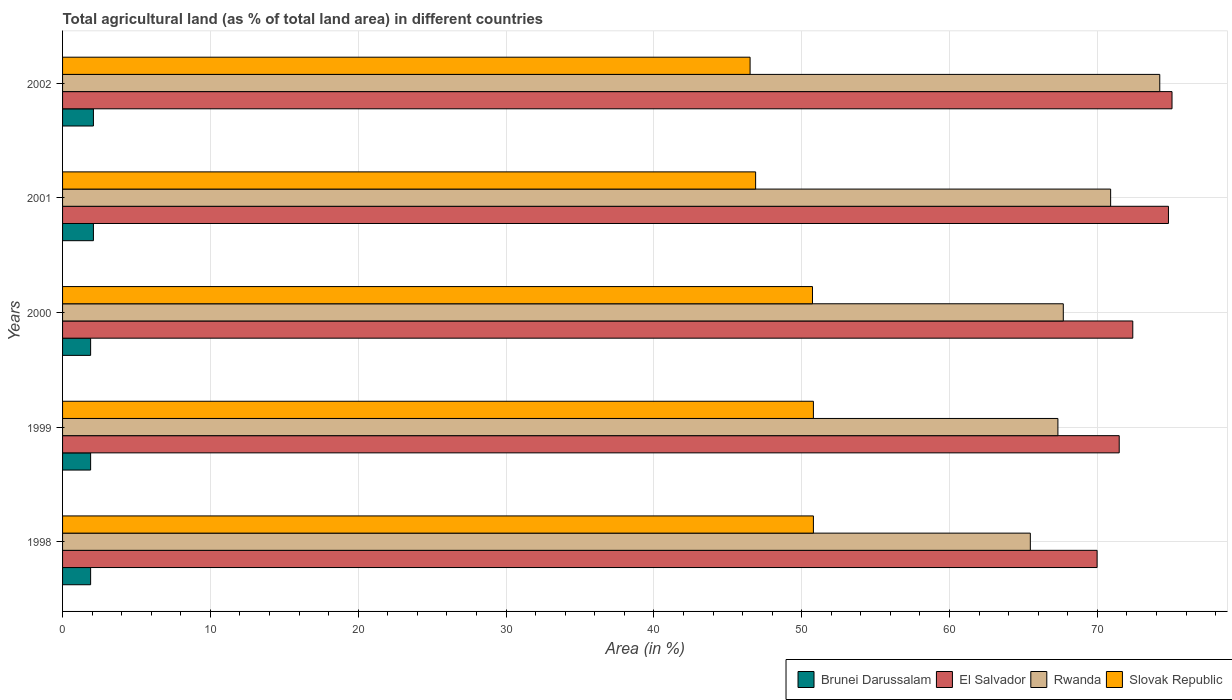How many different coloured bars are there?
Your response must be concise. 4. How many groups of bars are there?
Keep it short and to the point. 5. Are the number of bars per tick equal to the number of legend labels?
Your answer should be very brief. Yes. How many bars are there on the 1st tick from the bottom?
Ensure brevity in your answer.  4. What is the label of the 5th group of bars from the top?
Keep it short and to the point. 1998. In how many cases, is the number of bars for a given year not equal to the number of legend labels?
Ensure brevity in your answer.  0. What is the percentage of agricultural land in Brunei Darussalam in 1999?
Provide a succinct answer. 1.9. Across all years, what is the maximum percentage of agricultural land in El Salvador?
Provide a succinct answer. 75.05. Across all years, what is the minimum percentage of agricultural land in Slovak Republic?
Ensure brevity in your answer.  46.51. In which year was the percentage of agricultural land in Slovak Republic maximum?
Give a very brief answer. 1998. In which year was the percentage of agricultural land in Rwanda minimum?
Your answer should be very brief. 1998. What is the total percentage of agricultural land in El Salvador in the graph?
Provide a short and direct response. 363.71. What is the difference between the percentage of agricultural land in El Salvador in 1999 and that in 2000?
Provide a succinct answer. -0.92. What is the difference between the percentage of agricultural land in Rwanda in 2000 and the percentage of agricultural land in Slovak Republic in 2001?
Ensure brevity in your answer.  20.81. What is the average percentage of agricultural land in Slovak Republic per year?
Your answer should be very brief. 49.14. In the year 2002, what is the difference between the percentage of agricultural land in Rwanda and percentage of agricultural land in Slovak Republic?
Provide a succinct answer. 27.71. In how many years, is the percentage of agricultural land in Brunei Darussalam greater than 14 %?
Your answer should be very brief. 0. What is the ratio of the percentage of agricultural land in El Salvador in 1998 to that in 2000?
Your response must be concise. 0.97. What is the difference between the highest and the second highest percentage of agricultural land in Rwanda?
Provide a succinct answer. 3.32. What is the difference between the highest and the lowest percentage of agricultural land in Slovak Republic?
Keep it short and to the point. 4.28. Is it the case that in every year, the sum of the percentage of agricultural land in El Salvador and percentage of agricultural land in Slovak Republic is greater than the sum of percentage of agricultural land in Rwanda and percentage of agricultural land in Brunei Darussalam?
Offer a terse response. Yes. What does the 4th bar from the top in 1999 represents?
Offer a very short reply. Brunei Darussalam. What does the 1st bar from the bottom in 2001 represents?
Your response must be concise. Brunei Darussalam. Are all the bars in the graph horizontal?
Ensure brevity in your answer.  Yes. What is the difference between two consecutive major ticks on the X-axis?
Keep it short and to the point. 10. Does the graph contain grids?
Keep it short and to the point. Yes. How are the legend labels stacked?
Provide a short and direct response. Horizontal. What is the title of the graph?
Give a very brief answer. Total agricultural land (as % of total land area) in different countries. Does "Brunei Darussalam" appear as one of the legend labels in the graph?
Ensure brevity in your answer.  Yes. What is the label or title of the X-axis?
Provide a succinct answer. Area (in %). What is the label or title of the Y-axis?
Your response must be concise. Years. What is the Area (in %) of Brunei Darussalam in 1998?
Provide a succinct answer. 1.9. What is the Area (in %) of El Salvador in 1998?
Provide a succinct answer. 69.98. What is the Area (in %) in Rwanda in 1998?
Provide a succinct answer. 65.46. What is the Area (in %) of Slovak Republic in 1998?
Your answer should be very brief. 50.79. What is the Area (in %) in Brunei Darussalam in 1999?
Your response must be concise. 1.9. What is the Area (in %) of El Salvador in 1999?
Your answer should be compact. 71.48. What is the Area (in %) of Rwanda in 1999?
Your answer should be very brief. 67.33. What is the Area (in %) of Slovak Republic in 1999?
Provide a short and direct response. 50.79. What is the Area (in %) of Brunei Darussalam in 2000?
Keep it short and to the point. 1.9. What is the Area (in %) in El Salvador in 2000?
Ensure brevity in your answer.  72.39. What is the Area (in %) of Rwanda in 2000?
Your response must be concise. 67.69. What is the Area (in %) in Slovak Republic in 2000?
Keep it short and to the point. 50.73. What is the Area (in %) in Brunei Darussalam in 2001?
Make the answer very short. 2.09. What is the Area (in %) in El Salvador in 2001?
Ensure brevity in your answer.  74.81. What is the Area (in %) in Rwanda in 2001?
Your answer should be compact. 70.9. What is the Area (in %) in Slovak Republic in 2001?
Your answer should be very brief. 46.88. What is the Area (in %) in Brunei Darussalam in 2002?
Your response must be concise. 2.09. What is the Area (in %) of El Salvador in 2002?
Offer a terse response. 75.05. What is the Area (in %) in Rwanda in 2002?
Make the answer very short. 74.22. What is the Area (in %) in Slovak Republic in 2002?
Your answer should be very brief. 46.51. Across all years, what is the maximum Area (in %) in Brunei Darussalam?
Your answer should be very brief. 2.09. Across all years, what is the maximum Area (in %) of El Salvador?
Offer a very short reply. 75.05. Across all years, what is the maximum Area (in %) of Rwanda?
Your answer should be compact. 74.22. Across all years, what is the maximum Area (in %) in Slovak Republic?
Provide a succinct answer. 50.79. Across all years, what is the minimum Area (in %) of Brunei Darussalam?
Provide a short and direct response. 1.9. Across all years, what is the minimum Area (in %) in El Salvador?
Your response must be concise. 69.98. Across all years, what is the minimum Area (in %) in Rwanda?
Ensure brevity in your answer.  65.46. Across all years, what is the minimum Area (in %) of Slovak Republic?
Your answer should be compact. 46.51. What is the total Area (in %) of Brunei Darussalam in the graph?
Ensure brevity in your answer.  9.87. What is the total Area (in %) in El Salvador in the graph?
Keep it short and to the point. 363.71. What is the total Area (in %) in Rwanda in the graph?
Make the answer very short. 345.6. What is the total Area (in %) in Slovak Republic in the graph?
Give a very brief answer. 245.7. What is the difference between the Area (in %) of Brunei Darussalam in 1998 and that in 1999?
Offer a very short reply. 0. What is the difference between the Area (in %) in El Salvador in 1998 and that in 1999?
Offer a very short reply. -1.5. What is the difference between the Area (in %) of Rwanda in 1998 and that in 1999?
Offer a very short reply. -1.86. What is the difference between the Area (in %) in Slovak Republic in 1998 and that in 1999?
Offer a very short reply. 0. What is the difference between the Area (in %) in Brunei Darussalam in 1998 and that in 2000?
Your answer should be compact. 0. What is the difference between the Area (in %) of El Salvador in 1998 and that in 2000?
Your answer should be compact. -2.41. What is the difference between the Area (in %) in Rwanda in 1998 and that in 2000?
Ensure brevity in your answer.  -2.23. What is the difference between the Area (in %) in Slovak Republic in 1998 and that in 2000?
Provide a short and direct response. 0.06. What is the difference between the Area (in %) of Brunei Darussalam in 1998 and that in 2001?
Provide a short and direct response. -0.19. What is the difference between the Area (in %) in El Salvador in 1998 and that in 2001?
Provide a succinct answer. -4.83. What is the difference between the Area (in %) in Rwanda in 1998 and that in 2001?
Offer a very short reply. -5.43. What is the difference between the Area (in %) of Slovak Republic in 1998 and that in 2001?
Provide a succinct answer. 3.91. What is the difference between the Area (in %) in Brunei Darussalam in 1998 and that in 2002?
Offer a very short reply. -0.19. What is the difference between the Area (in %) in El Salvador in 1998 and that in 2002?
Provide a short and direct response. -5.07. What is the difference between the Area (in %) in Rwanda in 1998 and that in 2002?
Make the answer very short. -8.76. What is the difference between the Area (in %) in Slovak Republic in 1998 and that in 2002?
Make the answer very short. 4.28. What is the difference between the Area (in %) of Brunei Darussalam in 1999 and that in 2000?
Your response must be concise. 0. What is the difference between the Area (in %) of El Salvador in 1999 and that in 2000?
Offer a terse response. -0.92. What is the difference between the Area (in %) in Rwanda in 1999 and that in 2000?
Keep it short and to the point. -0.36. What is the difference between the Area (in %) in Slovak Republic in 1999 and that in 2000?
Your response must be concise. 0.06. What is the difference between the Area (in %) of Brunei Darussalam in 1999 and that in 2001?
Provide a short and direct response. -0.19. What is the difference between the Area (in %) of El Salvador in 1999 and that in 2001?
Make the answer very short. -3.33. What is the difference between the Area (in %) in Rwanda in 1999 and that in 2001?
Your response must be concise. -3.57. What is the difference between the Area (in %) in Slovak Republic in 1999 and that in 2001?
Your answer should be very brief. 3.91. What is the difference between the Area (in %) of Brunei Darussalam in 1999 and that in 2002?
Offer a terse response. -0.19. What is the difference between the Area (in %) in El Salvador in 1999 and that in 2002?
Your answer should be compact. -3.57. What is the difference between the Area (in %) in Rwanda in 1999 and that in 2002?
Ensure brevity in your answer.  -6.89. What is the difference between the Area (in %) in Slovak Republic in 1999 and that in 2002?
Offer a terse response. 4.28. What is the difference between the Area (in %) in Brunei Darussalam in 2000 and that in 2001?
Offer a terse response. -0.19. What is the difference between the Area (in %) in El Salvador in 2000 and that in 2001?
Offer a very short reply. -2.41. What is the difference between the Area (in %) in Rwanda in 2000 and that in 2001?
Your response must be concise. -3.2. What is the difference between the Area (in %) of Slovak Republic in 2000 and that in 2001?
Provide a succinct answer. 3.85. What is the difference between the Area (in %) of Brunei Darussalam in 2000 and that in 2002?
Offer a terse response. -0.19. What is the difference between the Area (in %) of El Salvador in 2000 and that in 2002?
Ensure brevity in your answer.  -2.65. What is the difference between the Area (in %) of Rwanda in 2000 and that in 2002?
Ensure brevity in your answer.  -6.53. What is the difference between the Area (in %) of Slovak Republic in 2000 and that in 2002?
Your answer should be very brief. 4.22. What is the difference between the Area (in %) in Brunei Darussalam in 2001 and that in 2002?
Offer a terse response. 0. What is the difference between the Area (in %) of El Salvador in 2001 and that in 2002?
Provide a succinct answer. -0.24. What is the difference between the Area (in %) of Rwanda in 2001 and that in 2002?
Your response must be concise. -3.32. What is the difference between the Area (in %) of Slovak Republic in 2001 and that in 2002?
Make the answer very short. 0.37. What is the difference between the Area (in %) in Brunei Darussalam in 1998 and the Area (in %) in El Salvador in 1999?
Keep it short and to the point. -69.58. What is the difference between the Area (in %) in Brunei Darussalam in 1998 and the Area (in %) in Rwanda in 1999?
Your response must be concise. -65.43. What is the difference between the Area (in %) in Brunei Darussalam in 1998 and the Area (in %) in Slovak Republic in 1999?
Your answer should be very brief. -48.89. What is the difference between the Area (in %) in El Salvador in 1998 and the Area (in %) in Rwanda in 1999?
Offer a very short reply. 2.65. What is the difference between the Area (in %) in El Salvador in 1998 and the Area (in %) in Slovak Republic in 1999?
Your answer should be very brief. 19.19. What is the difference between the Area (in %) of Rwanda in 1998 and the Area (in %) of Slovak Republic in 1999?
Give a very brief answer. 14.67. What is the difference between the Area (in %) in Brunei Darussalam in 1998 and the Area (in %) in El Salvador in 2000?
Your answer should be very brief. -70.5. What is the difference between the Area (in %) of Brunei Darussalam in 1998 and the Area (in %) of Rwanda in 2000?
Offer a terse response. -65.8. What is the difference between the Area (in %) of Brunei Darussalam in 1998 and the Area (in %) of Slovak Republic in 2000?
Offer a very short reply. -48.83. What is the difference between the Area (in %) of El Salvador in 1998 and the Area (in %) of Rwanda in 2000?
Your answer should be very brief. 2.29. What is the difference between the Area (in %) of El Salvador in 1998 and the Area (in %) of Slovak Republic in 2000?
Ensure brevity in your answer.  19.25. What is the difference between the Area (in %) in Rwanda in 1998 and the Area (in %) in Slovak Republic in 2000?
Make the answer very short. 14.74. What is the difference between the Area (in %) in Brunei Darussalam in 1998 and the Area (in %) in El Salvador in 2001?
Offer a very short reply. -72.91. What is the difference between the Area (in %) in Brunei Darussalam in 1998 and the Area (in %) in Rwanda in 2001?
Ensure brevity in your answer.  -69. What is the difference between the Area (in %) of Brunei Darussalam in 1998 and the Area (in %) of Slovak Republic in 2001?
Provide a succinct answer. -44.98. What is the difference between the Area (in %) in El Salvador in 1998 and the Area (in %) in Rwanda in 2001?
Your answer should be compact. -0.92. What is the difference between the Area (in %) in El Salvador in 1998 and the Area (in %) in Slovak Republic in 2001?
Keep it short and to the point. 23.1. What is the difference between the Area (in %) of Rwanda in 1998 and the Area (in %) of Slovak Republic in 2001?
Your response must be concise. 18.58. What is the difference between the Area (in %) of Brunei Darussalam in 1998 and the Area (in %) of El Salvador in 2002?
Make the answer very short. -73.15. What is the difference between the Area (in %) in Brunei Darussalam in 1998 and the Area (in %) in Rwanda in 2002?
Your response must be concise. -72.32. What is the difference between the Area (in %) in Brunei Darussalam in 1998 and the Area (in %) in Slovak Republic in 2002?
Provide a short and direct response. -44.61. What is the difference between the Area (in %) of El Salvador in 1998 and the Area (in %) of Rwanda in 2002?
Your answer should be compact. -4.24. What is the difference between the Area (in %) in El Salvador in 1998 and the Area (in %) in Slovak Republic in 2002?
Your answer should be very brief. 23.47. What is the difference between the Area (in %) of Rwanda in 1998 and the Area (in %) of Slovak Republic in 2002?
Provide a short and direct response. 18.96. What is the difference between the Area (in %) in Brunei Darussalam in 1999 and the Area (in %) in El Salvador in 2000?
Your response must be concise. -70.5. What is the difference between the Area (in %) in Brunei Darussalam in 1999 and the Area (in %) in Rwanda in 2000?
Offer a terse response. -65.8. What is the difference between the Area (in %) of Brunei Darussalam in 1999 and the Area (in %) of Slovak Republic in 2000?
Provide a short and direct response. -48.83. What is the difference between the Area (in %) of El Salvador in 1999 and the Area (in %) of Rwanda in 2000?
Give a very brief answer. 3.78. What is the difference between the Area (in %) in El Salvador in 1999 and the Area (in %) in Slovak Republic in 2000?
Keep it short and to the point. 20.75. What is the difference between the Area (in %) in Rwanda in 1999 and the Area (in %) in Slovak Republic in 2000?
Provide a succinct answer. 16.6. What is the difference between the Area (in %) in Brunei Darussalam in 1999 and the Area (in %) in El Salvador in 2001?
Provide a succinct answer. -72.91. What is the difference between the Area (in %) of Brunei Darussalam in 1999 and the Area (in %) of Rwanda in 2001?
Make the answer very short. -69. What is the difference between the Area (in %) in Brunei Darussalam in 1999 and the Area (in %) in Slovak Republic in 2001?
Offer a terse response. -44.98. What is the difference between the Area (in %) in El Salvador in 1999 and the Area (in %) in Rwanda in 2001?
Keep it short and to the point. 0.58. What is the difference between the Area (in %) of El Salvador in 1999 and the Area (in %) of Slovak Republic in 2001?
Your response must be concise. 24.6. What is the difference between the Area (in %) in Rwanda in 1999 and the Area (in %) in Slovak Republic in 2001?
Your answer should be very brief. 20.45. What is the difference between the Area (in %) in Brunei Darussalam in 1999 and the Area (in %) in El Salvador in 2002?
Provide a succinct answer. -73.15. What is the difference between the Area (in %) of Brunei Darussalam in 1999 and the Area (in %) of Rwanda in 2002?
Offer a very short reply. -72.32. What is the difference between the Area (in %) in Brunei Darussalam in 1999 and the Area (in %) in Slovak Republic in 2002?
Provide a short and direct response. -44.61. What is the difference between the Area (in %) of El Salvador in 1999 and the Area (in %) of Rwanda in 2002?
Your answer should be very brief. -2.74. What is the difference between the Area (in %) in El Salvador in 1999 and the Area (in %) in Slovak Republic in 2002?
Provide a succinct answer. 24.97. What is the difference between the Area (in %) in Rwanda in 1999 and the Area (in %) in Slovak Republic in 2002?
Offer a very short reply. 20.82. What is the difference between the Area (in %) in Brunei Darussalam in 2000 and the Area (in %) in El Salvador in 2001?
Keep it short and to the point. -72.91. What is the difference between the Area (in %) of Brunei Darussalam in 2000 and the Area (in %) of Rwanda in 2001?
Give a very brief answer. -69. What is the difference between the Area (in %) in Brunei Darussalam in 2000 and the Area (in %) in Slovak Republic in 2001?
Offer a terse response. -44.98. What is the difference between the Area (in %) of El Salvador in 2000 and the Area (in %) of Rwanda in 2001?
Keep it short and to the point. 1.5. What is the difference between the Area (in %) in El Salvador in 2000 and the Area (in %) in Slovak Republic in 2001?
Make the answer very short. 25.51. What is the difference between the Area (in %) in Rwanda in 2000 and the Area (in %) in Slovak Republic in 2001?
Your answer should be very brief. 20.81. What is the difference between the Area (in %) of Brunei Darussalam in 2000 and the Area (in %) of El Salvador in 2002?
Keep it short and to the point. -73.15. What is the difference between the Area (in %) of Brunei Darussalam in 2000 and the Area (in %) of Rwanda in 2002?
Your response must be concise. -72.32. What is the difference between the Area (in %) in Brunei Darussalam in 2000 and the Area (in %) in Slovak Republic in 2002?
Make the answer very short. -44.61. What is the difference between the Area (in %) in El Salvador in 2000 and the Area (in %) in Rwanda in 2002?
Provide a succinct answer. -1.83. What is the difference between the Area (in %) of El Salvador in 2000 and the Area (in %) of Slovak Republic in 2002?
Provide a short and direct response. 25.89. What is the difference between the Area (in %) of Rwanda in 2000 and the Area (in %) of Slovak Republic in 2002?
Make the answer very short. 21.19. What is the difference between the Area (in %) of Brunei Darussalam in 2001 and the Area (in %) of El Salvador in 2002?
Provide a succinct answer. -72.96. What is the difference between the Area (in %) of Brunei Darussalam in 2001 and the Area (in %) of Rwanda in 2002?
Make the answer very short. -72.13. What is the difference between the Area (in %) in Brunei Darussalam in 2001 and the Area (in %) in Slovak Republic in 2002?
Your answer should be compact. -44.42. What is the difference between the Area (in %) of El Salvador in 2001 and the Area (in %) of Rwanda in 2002?
Your answer should be very brief. 0.59. What is the difference between the Area (in %) in El Salvador in 2001 and the Area (in %) in Slovak Republic in 2002?
Make the answer very short. 28.3. What is the difference between the Area (in %) in Rwanda in 2001 and the Area (in %) in Slovak Republic in 2002?
Ensure brevity in your answer.  24.39. What is the average Area (in %) in Brunei Darussalam per year?
Your answer should be compact. 1.97. What is the average Area (in %) in El Salvador per year?
Your response must be concise. 72.74. What is the average Area (in %) in Rwanda per year?
Your answer should be compact. 69.12. What is the average Area (in %) in Slovak Republic per year?
Give a very brief answer. 49.14. In the year 1998, what is the difference between the Area (in %) of Brunei Darussalam and Area (in %) of El Salvador?
Provide a succinct answer. -68.08. In the year 1998, what is the difference between the Area (in %) in Brunei Darussalam and Area (in %) in Rwanda?
Offer a very short reply. -63.57. In the year 1998, what is the difference between the Area (in %) in Brunei Darussalam and Area (in %) in Slovak Republic?
Give a very brief answer. -48.89. In the year 1998, what is the difference between the Area (in %) in El Salvador and Area (in %) in Rwanda?
Your answer should be very brief. 4.52. In the year 1998, what is the difference between the Area (in %) of El Salvador and Area (in %) of Slovak Republic?
Make the answer very short. 19.19. In the year 1998, what is the difference between the Area (in %) in Rwanda and Area (in %) in Slovak Republic?
Your answer should be compact. 14.67. In the year 1999, what is the difference between the Area (in %) of Brunei Darussalam and Area (in %) of El Salvador?
Offer a very short reply. -69.58. In the year 1999, what is the difference between the Area (in %) in Brunei Darussalam and Area (in %) in Rwanda?
Make the answer very short. -65.43. In the year 1999, what is the difference between the Area (in %) of Brunei Darussalam and Area (in %) of Slovak Republic?
Offer a terse response. -48.89. In the year 1999, what is the difference between the Area (in %) of El Salvador and Area (in %) of Rwanda?
Keep it short and to the point. 4.15. In the year 1999, what is the difference between the Area (in %) in El Salvador and Area (in %) in Slovak Republic?
Make the answer very short. 20.69. In the year 1999, what is the difference between the Area (in %) in Rwanda and Area (in %) in Slovak Republic?
Keep it short and to the point. 16.54. In the year 2000, what is the difference between the Area (in %) in Brunei Darussalam and Area (in %) in El Salvador?
Provide a short and direct response. -70.5. In the year 2000, what is the difference between the Area (in %) of Brunei Darussalam and Area (in %) of Rwanda?
Give a very brief answer. -65.8. In the year 2000, what is the difference between the Area (in %) of Brunei Darussalam and Area (in %) of Slovak Republic?
Provide a short and direct response. -48.83. In the year 2000, what is the difference between the Area (in %) of El Salvador and Area (in %) of Rwanda?
Offer a very short reply. 4.7. In the year 2000, what is the difference between the Area (in %) in El Salvador and Area (in %) in Slovak Republic?
Offer a very short reply. 21.67. In the year 2000, what is the difference between the Area (in %) of Rwanda and Area (in %) of Slovak Republic?
Keep it short and to the point. 16.97. In the year 2001, what is the difference between the Area (in %) of Brunei Darussalam and Area (in %) of El Salvador?
Give a very brief answer. -72.72. In the year 2001, what is the difference between the Area (in %) in Brunei Darussalam and Area (in %) in Rwanda?
Keep it short and to the point. -68.81. In the year 2001, what is the difference between the Area (in %) in Brunei Darussalam and Area (in %) in Slovak Republic?
Ensure brevity in your answer.  -44.79. In the year 2001, what is the difference between the Area (in %) in El Salvador and Area (in %) in Rwanda?
Your answer should be compact. 3.91. In the year 2001, what is the difference between the Area (in %) of El Salvador and Area (in %) of Slovak Republic?
Your answer should be very brief. 27.93. In the year 2001, what is the difference between the Area (in %) of Rwanda and Area (in %) of Slovak Republic?
Keep it short and to the point. 24.01. In the year 2002, what is the difference between the Area (in %) in Brunei Darussalam and Area (in %) in El Salvador?
Give a very brief answer. -72.96. In the year 2002, what is the difference between the Area (in %) in Brunei Darussalam and Area (in %) in Rwanda?
Provide a short and direct response. -72.13. In the year 2002, what is the difference between the Area (in %) in Brunei Darussalam and Area (in %) in Slovak Republic?
Make the answer very short. -44.42. In the year 2002, what is the difference between the Area (in %) in El Salvador and Area (in %) in Rwanda?
Your response must be concise. 0.83. In the year 2002, what is the difference between the Area (in %) of El Salvador and Area (in %) of Slovak Republic?
Make the answer very short. 28.54. In the year 2002, what is the difference between the Area (in %) of Rwanda and Area (in %) of Slovak Republic?
Your answer should be very brief. 27.71. What is the ratio of the Area (in %) of El Salvador in 1998 to that in 1999?
Keep it short and to the point. 0.98. What is the ratio of the Area (in %) of Rwanda in 1998 to that in 1999?
Provide a short and direct response. 0.97. What is the ratio of the Area (in %) of Slovak Republic in 1998 to that in 1999?
Make the answer very short. 1. What is the ratio of the Area (in %) in Brunei Darussalam in 1998 to that in 2000?
Ensure brevity in your answer.  1. What is the ratio of the Area (in %) of El Salvador in 1998 to that in 2000?
Make the answer very short. 0.97. What is the ratio of the Area (in %) of Rwanda in 1998 to that in 2000?
Your answer should be compact. 0.97. What is the ratio of the Area (in %) in El Salvador in 1998 to that in 2001?
Keep it short and to the point. 0.94. What is the ratio of the Area (in %) in Rwanda in 1998 to that in 2001?
Your answer should be very brief. 0.92. What is the ratio of the Area (in %) in Slovak Republic in 1998 to that in 2001?
Your response must be concise. 1.08. What is the ratio of the Area (in %) in Brunei Darussalam in 1998 to that in 2002?
Provide a succinct answer. 0.91. What is the ratio of the Area (in %) of El Salvador in 1998 to that in 2002?
Your response must be concise. 0.93. What is the ratio of the Area (in %) in Rwanda in 1998 to that in 2002?
Provide a short and direct response. 0.88. What is the ratio of the Area (in %) in Slovak Republic in 1998 to that in 2002?
Your response must be concise. 1.09. What is the ratio of the Area (in %) of El Salvador in 1999 to that in 2000?
Keep it short and to the point. 0.99. What is the ratio of the Area (in %) in Rwanda in 1999 to that in 2000?
Provide a short and direct response. 0.99. What is the ratio of the Area (in %) in Slovak Republic in 1999 to that in 2000?
Give a very brief answer. 1. What is the ratio of the Area (in %) of El Salvador in 1999 to that in 2001?
Offer a terse response. 0.96. What is the ratio of the Area (in %) in Rwanda in 1999 to that in 2001?
Keep it short and to the point. 0.95. What is the ratio of the Area (in %) of Slovak Republic in 1999 to that in 2001?
Ensure brevity in your answer.  1.08. What is the ratio of the Area (in %) of Brunei Darussalam in 1999 to that in 2002?
Your answer should be very brief. 0.91. What is the ratio of the Area (in %) in Rwanda in 1999 to that in 2002?
Your answer should be very brief. 0.91. What is the ratio of the Area (in %) of Slovak Republic in 1999 to that in 2002?
Keep it short and to the point. 1.09. What is the ratio of the Area (in %) of El Salvador in 2000 to that in 2001?
Provide a succinct answer. 0.97. What is the ratio of the Area (in %) of Rwanda in 2000 to that in 2001?
Your answer should be compact. 0.95. What is the ratio of the Area (in %) in Slovak Republic in 2000 to that in 2001?
Your answer should be very brief. 1.08. What is the ratio of the Area (in %) in Brunei Darussalam in 2000 to that in 2002?
Your answer should be compact. 0.91. What is the ratio of the Area (in %) of El Salvador in 2000 to that in 2002?
Your answer should be very brief. 0.96. What is the ratio of the Area (in %) in Rwanda in 2000 to that in 2002?
Provide a short and direct response. 0.91. What is the ratio of the Area (in %) in Slovak Republic in 2000 to that in 2002?
Offer a very short reply. 1.09. What is the ratio of the Area (in %) of Rwanda in 2001 to that in 2002?
Keep it short and to the point. 0.96. What is the difference between the highest and the second highest Area (in %) in El Salvador?
Offer a very short reply. 0.24. What is the difference between the highest and the second highest Area (in %) of Rwanda?
Offer a terse response. 3.32. What is the difference between the highest and the second highest Area (in %) of Slovak Republic?
Keep it short and to the point. 0. What is the difference between the highest and the lowest Area (in %) in Brunei Darussalam?
Keep it short and to the point. 0.19. What is the difference between the highest and the lowest Area (in %) of El Salvador?
Give a very brief answer. 5.07. What is the difference between the highest and the lowest Area (in %) in Rwanda?
Make the answer very short. 8.76. What is the difference between the highest and the lowest Area (in %) in Slovak Republic?
Provide a succinct answer. 4.28. 